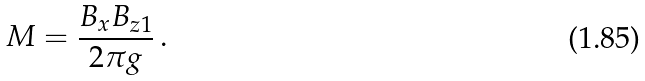Convert formula to latex. <formula><loc_0><loc_0><loc_500><loc_500>M = \frac { B _ { x } B _ { z 1 } } { 2 \pi g } \, .</formula> 